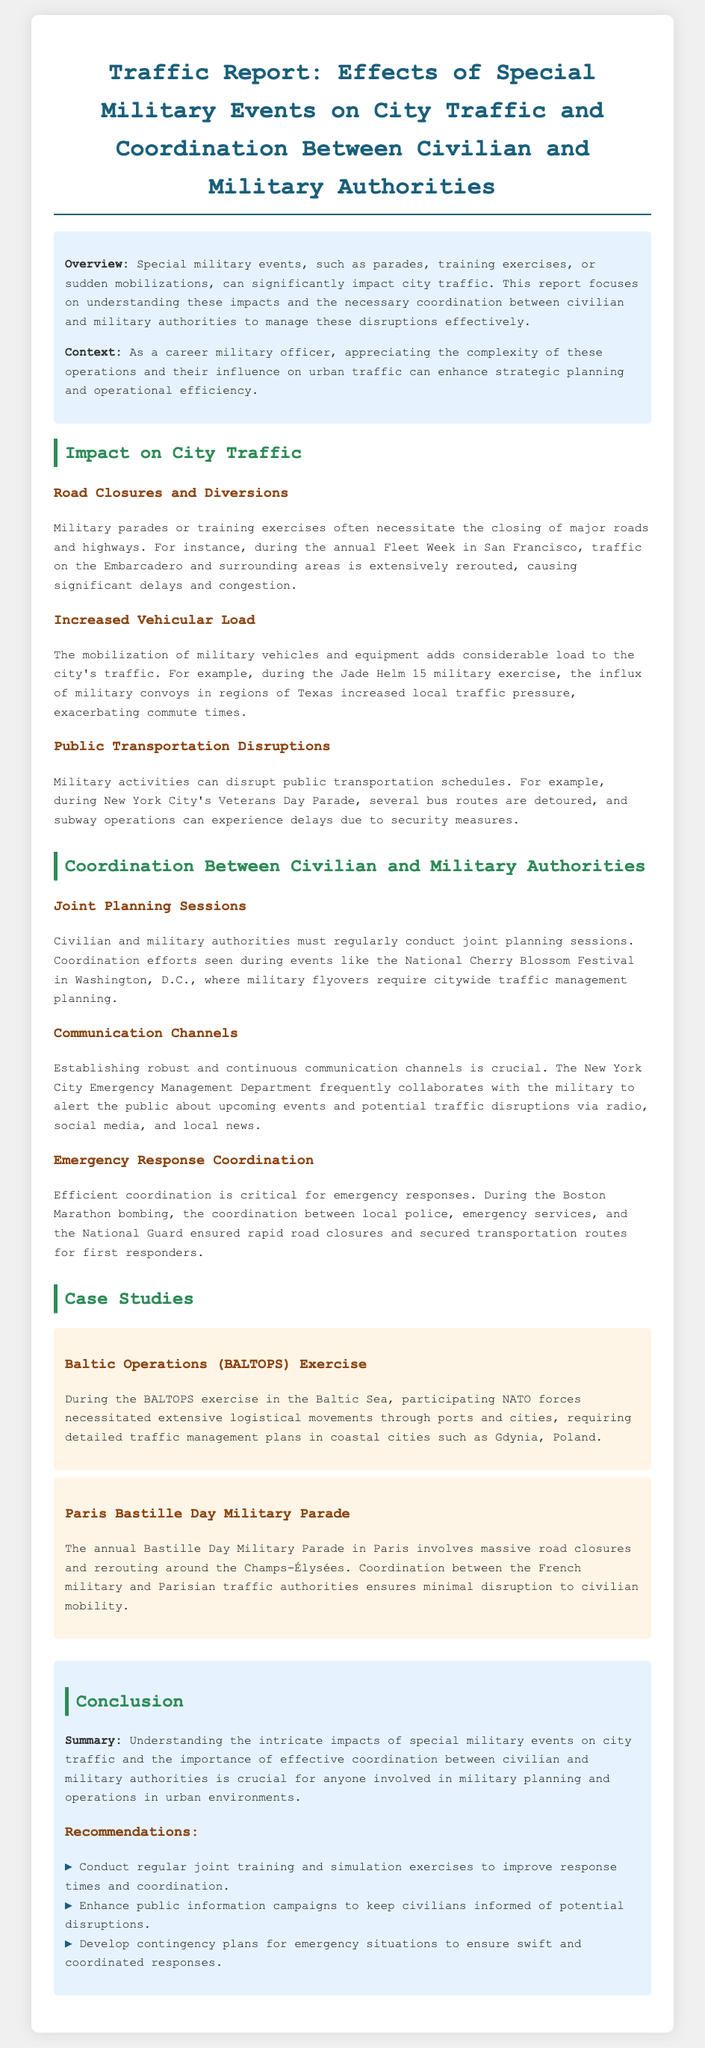What is the overview of the report? The overview provides a summary of how special military events impact city traffic and the coordination required between authorities.
Answer: Special military events can significantly impact city traffic During which event are major road closures noted? The document cites the annual Fleet Week in San Francisco as an example of significant road closures.
Answer: Fleet Week What is mentioned about public transportation during military activities? Disruptions are noted in public transport schedules during events like the Veterans Day Parade in New York City.
Answer: Disrupted schedules What kind of cooperation is emphasized between authorities? The report emphasizes conducting regular joint planning sessions between civilian and military authorities.
Answer: Joint planning sessions Which military exercise increased local traffic pressure? The Jade Helm 15 military exercise is identified as increasing local traffic pressure in Texas.
Answer: Jade Helm 15 What communication method is frequently used to inform the public about disruptions? The document mentions the use of social media as one of the communication channels to alert the public.
Answer: Social media What has been a crucial aspect of emergency response coordination? The rapid road closures and secure transport routes for first responders during the Boston Marathon bombing highlight this aspect.
Answer: Coordination of road closures How does the report suggest improving coordination? It recommends conducting regular joint training and simulation exercises to enhance coordination.
Answer: Regular joint training What event is cited for traffic management planning during military flyovers? The National Cherry Blossom Festival is referenced for its traffic management planning related to military flyovers.
Answer: National Cherry Blossom Festival 